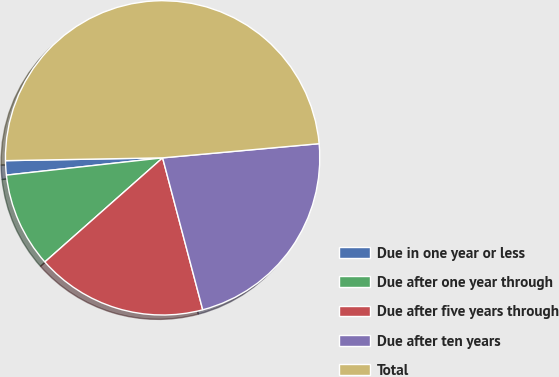Convert chart to OTSL. <chart><loc_0><loc_0><loc_500><loc_500><pie_chart><fcel>Due in one year or less<fcel>Due after one year through<fcel>Due after five years through<fcel>Due after ten years<fcel>Total<nl><fcel>1.47%<fcel>9.77%<fcel>17.59%<fcel>22.33%<fcel>48.85%<nl></chart> 